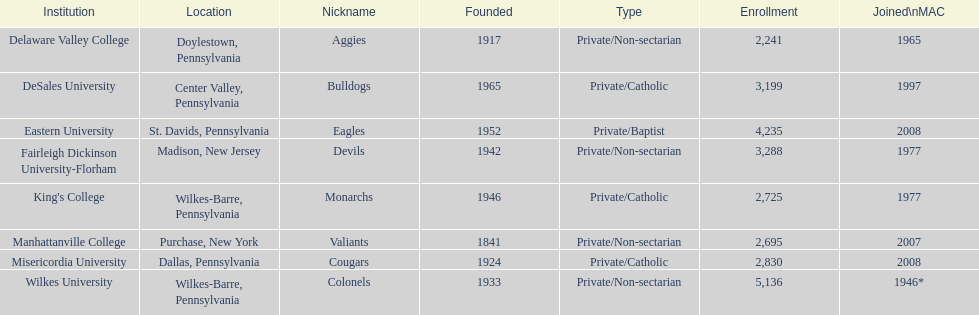Name each institution with enrollment numbers above 4,000? Eastern University, Wilkes University. 